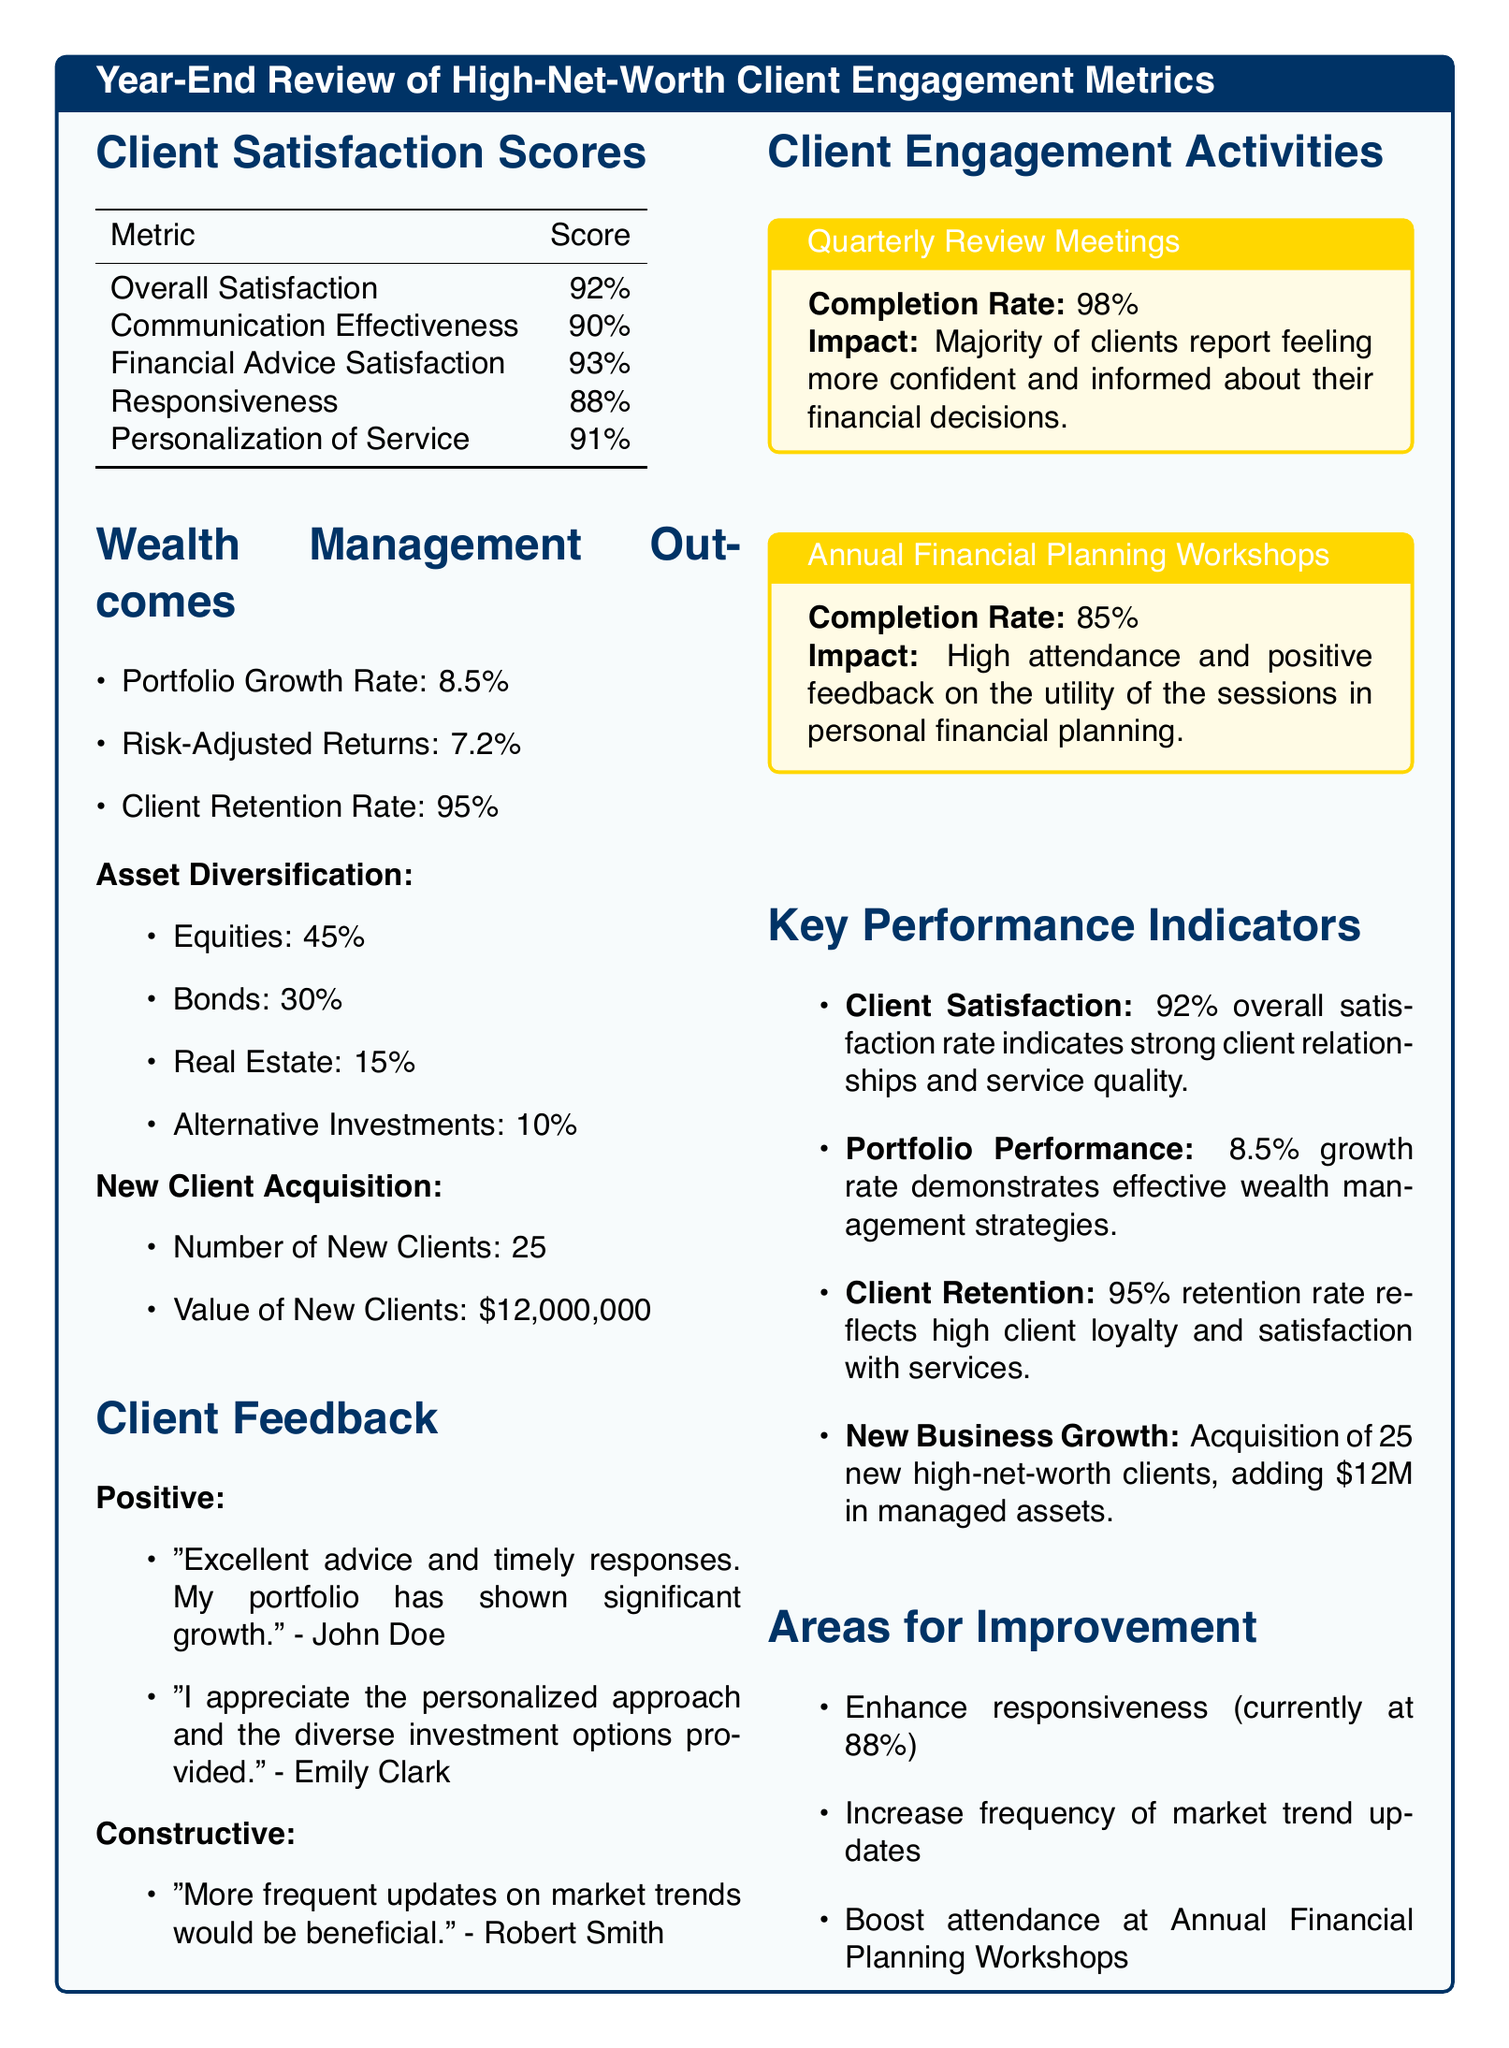What is the overall client satisfaction score? The overall client satisfaction score is directly stated in the document.
Answer: 92% What is the completion rate for Quarterly Review Meetings? The completion rate for Quarterly Review Meetings is provided in the Client Engagement Activities section.
Answer: 98% How many new clients were acquired? The document specifies the number of new clients acquired in the New Client Acquisition section.
Answer: 25 What is the portfolio growth rate? The portfolio growth rate is listed under Wealth Management Outcomes, providing specific performance metrics.
Answer: 8.5% What was the feedback from Robert Smith? The document includes client feedback under the Client Feedback section, highlighting constructive comments.
Answer: More frequent updates on market trends would be beneficial What percentage of clients are satisfied with financial advice? The satisfaction score for financial advice is mentioned in the Client Satisfaction Scores section.
Answer: 93% What is the client retention rate? The client retention rate is provided under Wealth Management Outcomes, summarizing client loyalty metrics.
Answer: 95% How much value was added by new clients? The value of new clients is specified in the New Client Acquisition section, indicating the financial impact of new business.
Answer: $12,000,000 What area needs improvement related to responsiveness? The Areas for Improvement section indicates specific areas that require attention, including responsiveness levels.
Answer: Enhance responsiveness 